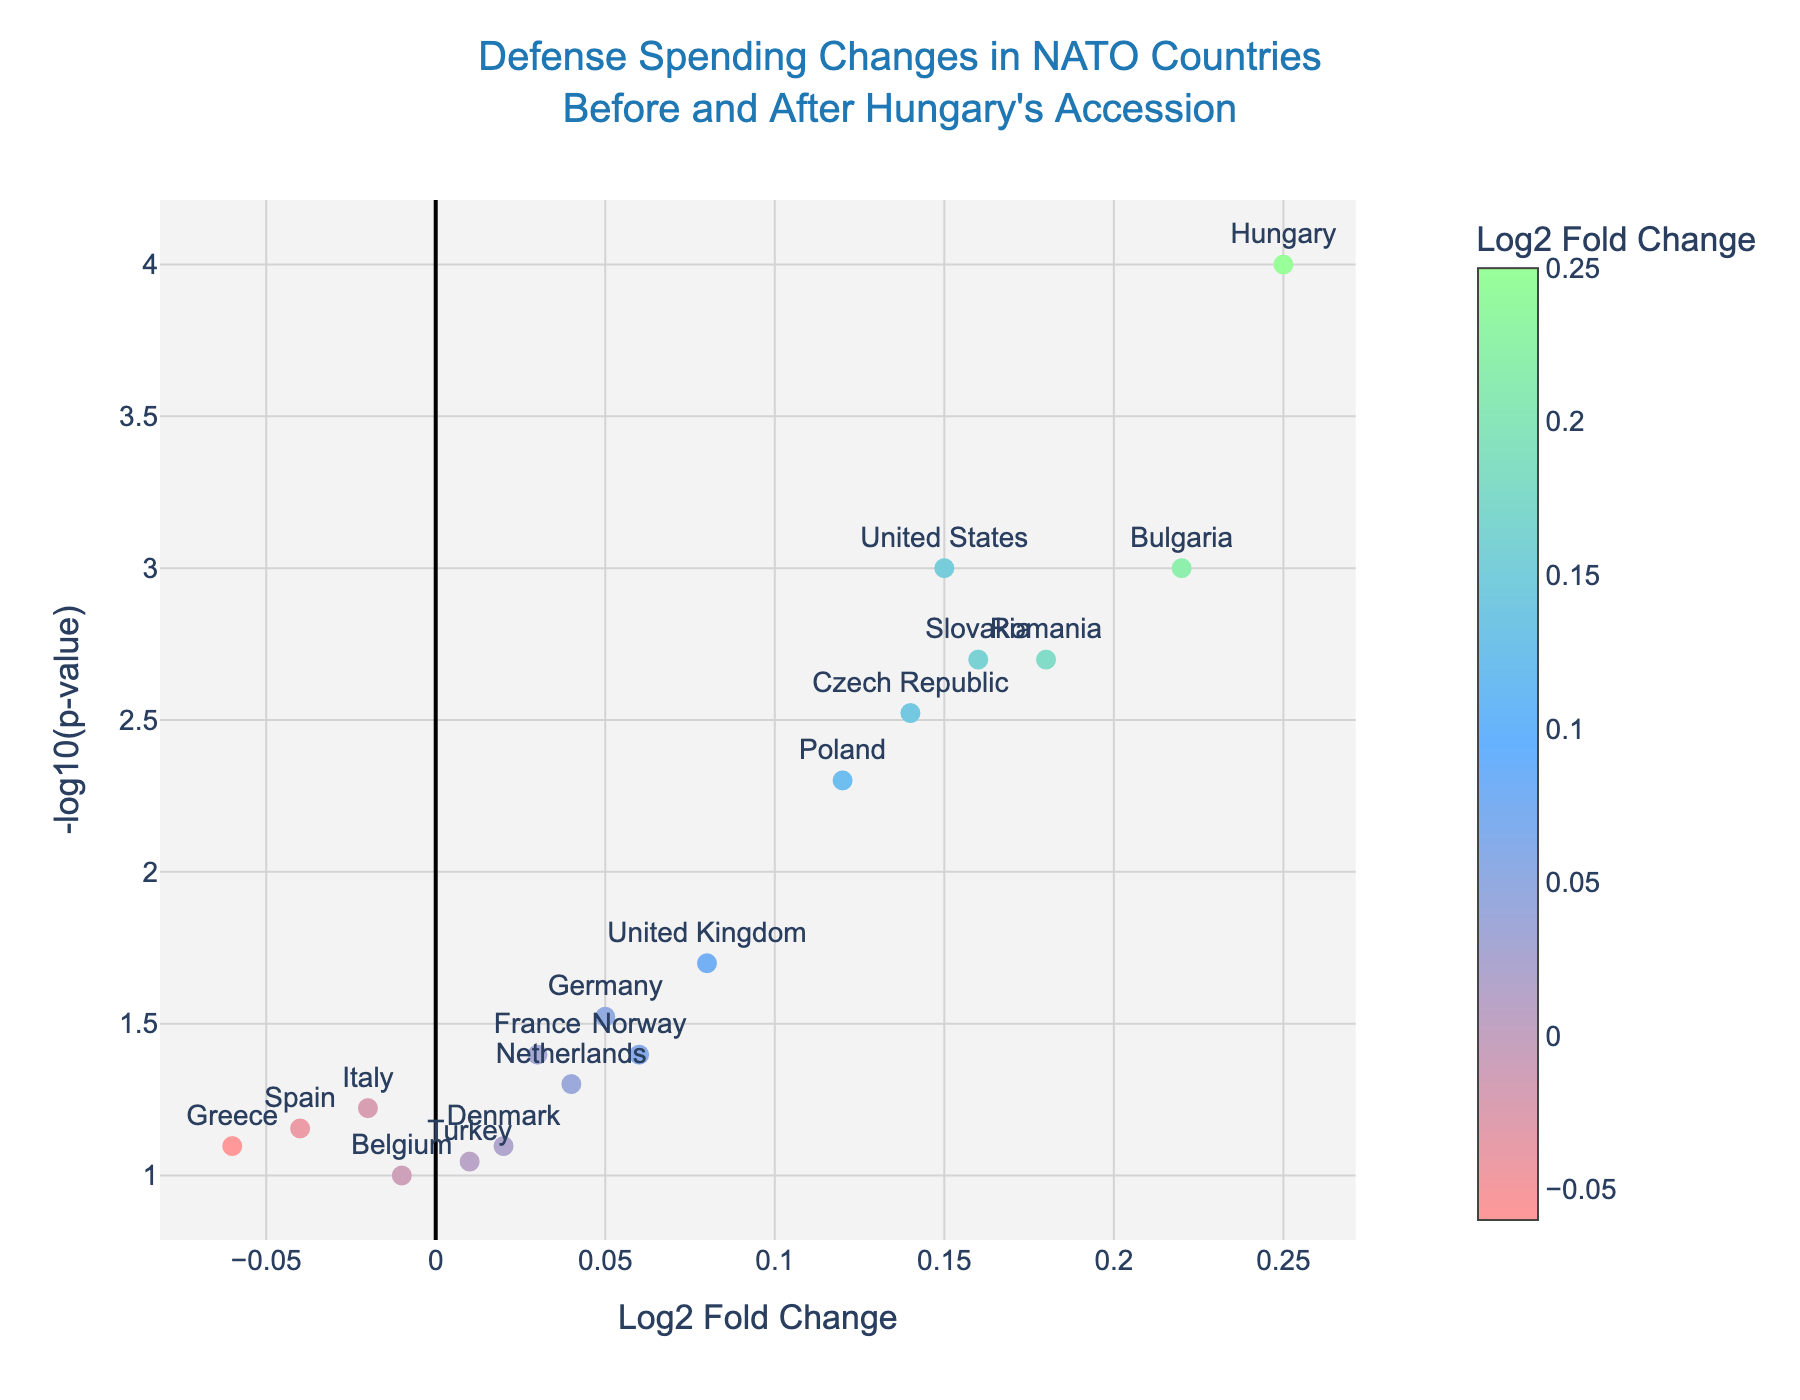what is the title of the plot? The title is located at the top of the plot. It reads: "Defense Spending Changes in NATO Countries Before and After Hungary's Accession"
Answer: Defense Spending Changes in NATO Countries Before and After Hungary's Accession How many countries show a positive log2 fold change in defense spending? By counting the data points that are positioned to the right of the vertical axis (Log2 Fold Change > 0) in the plot, we can see which countries have a positive change. These are the points for the United States, United Kingdom, Germany, France, Poland, Romania, Bulgaria, Norway, Czech Republic, Slovakia, and Hungary.
Answer: 11 Which country has the highest negative log10(p-value)? The plot shows -log10(p-value) on the y-axis, we look for the point located the highest on this axis. Hungary's point is the highest.
Answer: Hungary Compare the log2 fold change of Hungary and Italy. What is the difference? Hungary's log2 fold change is 0.25, and Italy's is -0.02. The difference is calculated by subtracting Italy's value from Hungary's.
Answer: 0.27 Which country has the smallest change in defense spending (log2 fold change closest to 0)? We look for the point nearest to the Log2 Fold Change value of 0. Turkey has the smallest change with a Log2 Fold Change of 0.01.
Answer: Turkey How many countries have a p-value less than 0.05? In the plot, the y-axis represents -log10(p-value). To find points with a p-value less than 0.05, we look for points with -log10(p-value) greater than 1.3010. The countries meeting this criteria are United States, United Kingdom, Germany, France, Poland, Romania, Bulgaria, Czech Republic, Slovakia, and Hungary.
Answer: 10 What is the average log2 fold change of Poland, Romania, and Bulgaria? To find the average, we add the log2 fold changes of these countries (0.12 + 0.18 + 0.22) and divide by 3.
Answer: 0.17 Which country has the p-value closest to 0.05? In the plot, -log10(0.05) is approximately 1.3010. The point closest to this y-axis value is for the Netherlands.
Answer: Netherlands Which country shows the highest increase in defense spending? The country represented by the point with highest positive log2 fold change value is Hungary, with a value of 0.25.
Answer: Hungary 